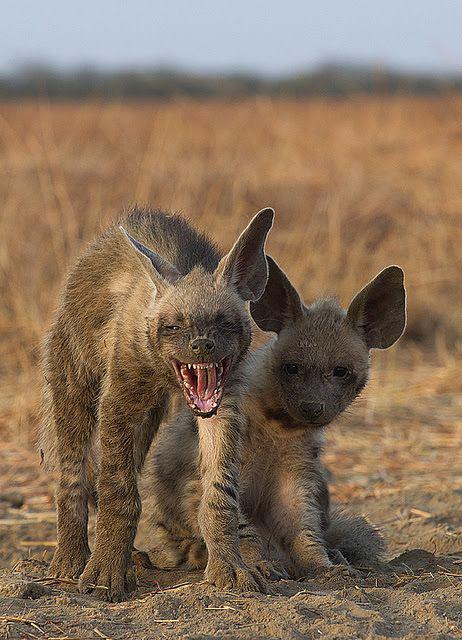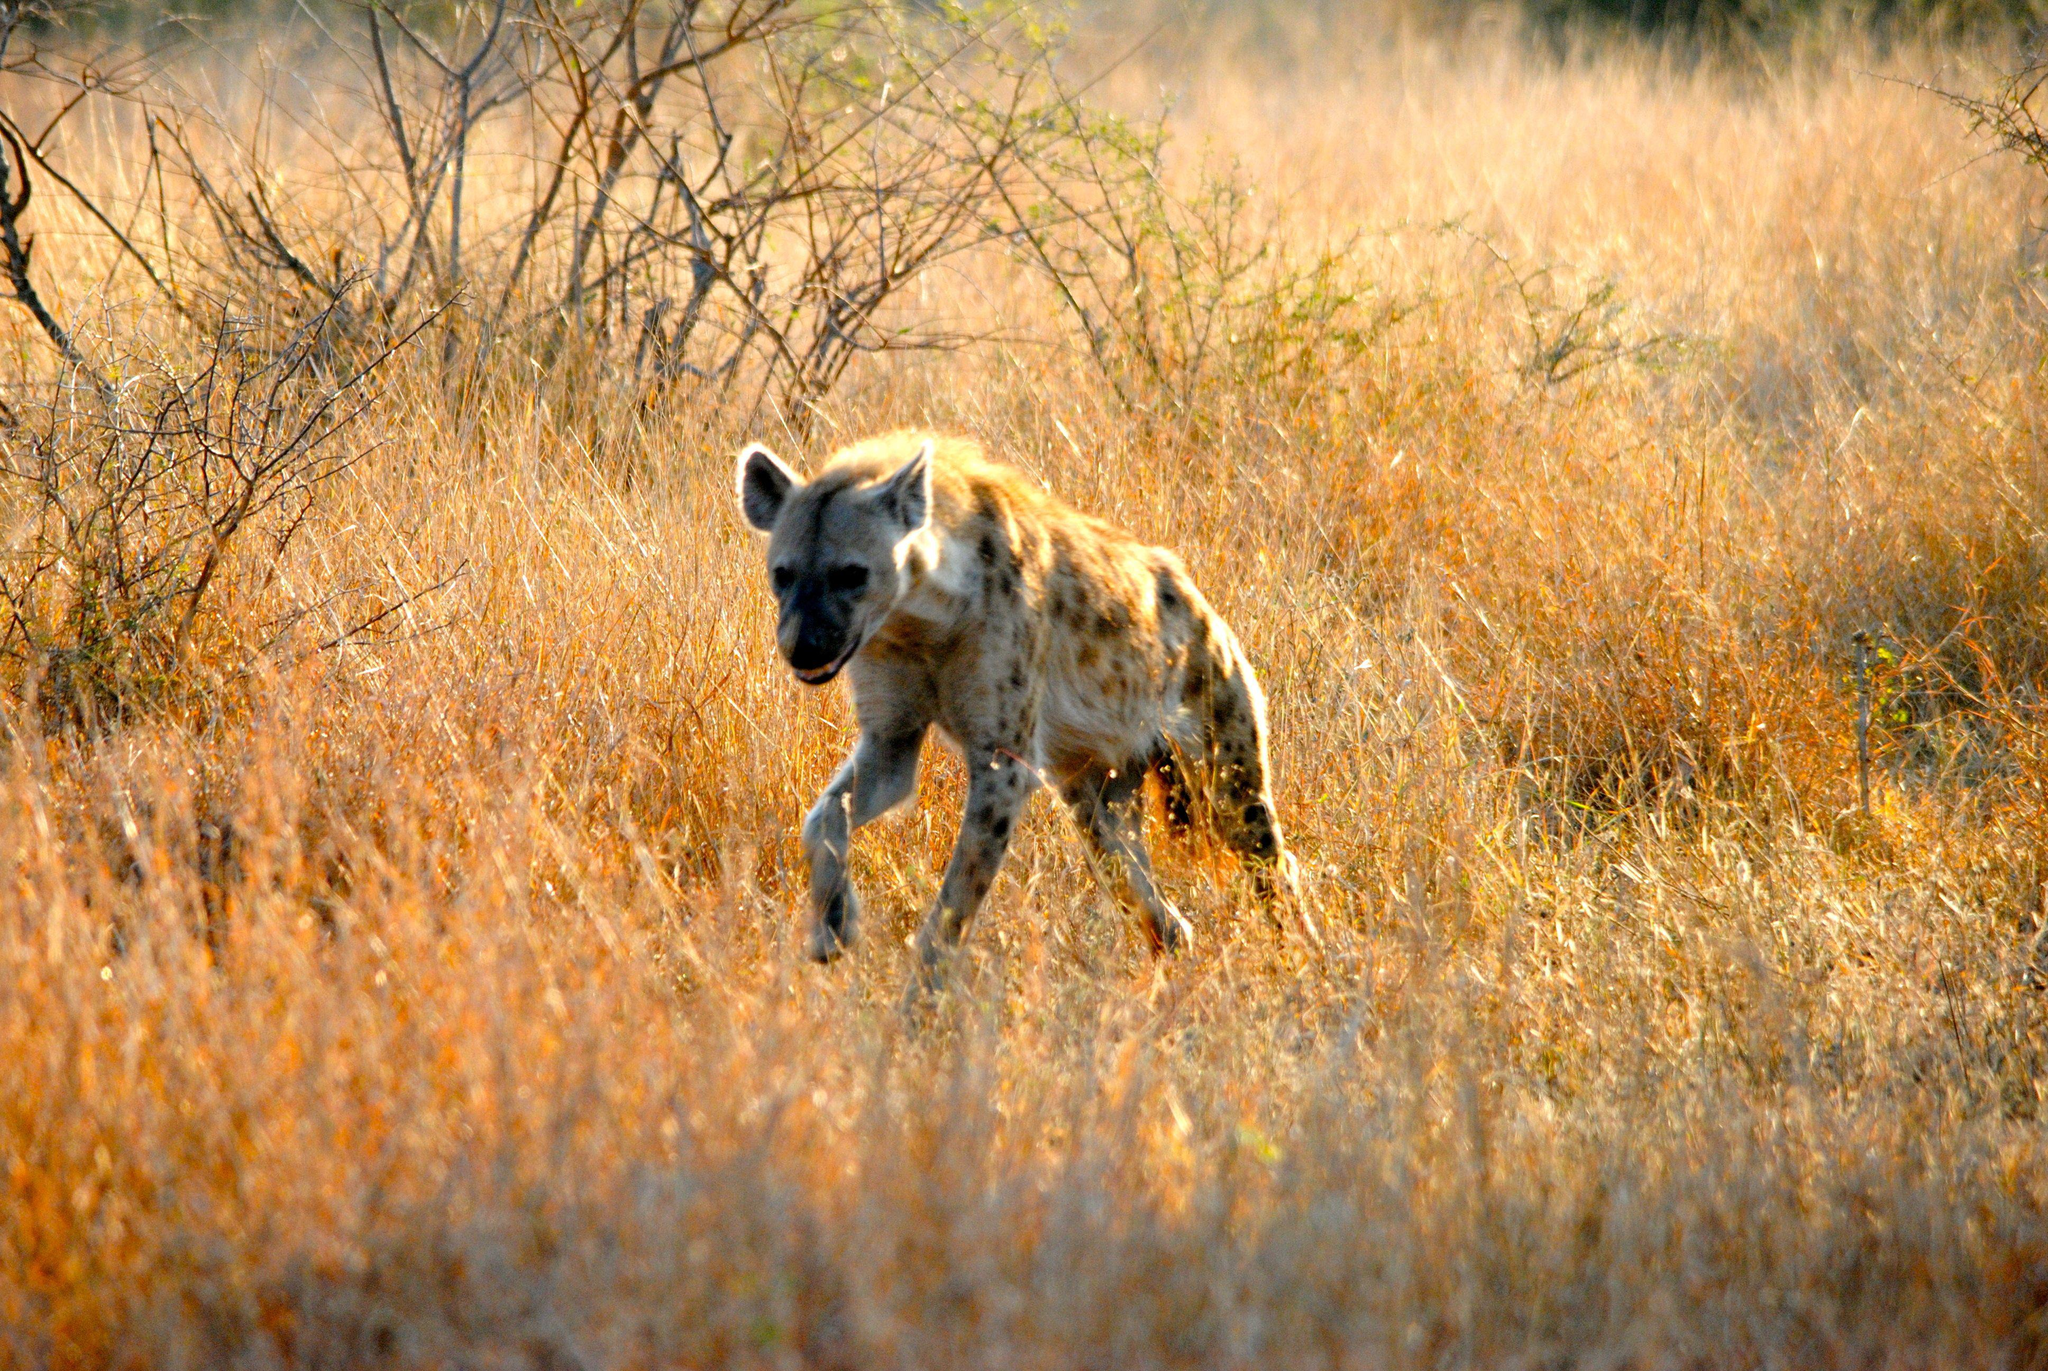The first image is the image on the left, the second image is the image on the right. Given the left and right images, does the statement "One image shows a single hyena moving forward and slightly to the left, and the other image includes a hyena with a wide-open fang-baring mouth and its body facing forward." hold true? Answer yes or no. Yes. The first image is the image on the left, the second image is the image on the right. Examine the images to the left and right. Is the description "There are two hyenas." accurate? Answer yes or no. No. 